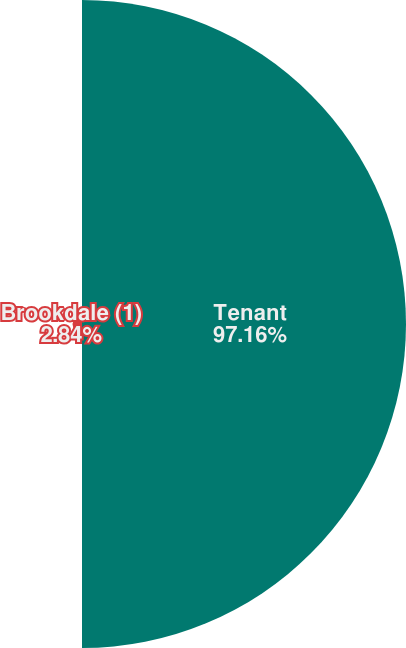Convert chart. <chart><loc_0><loc_0><loc_500><loc_500><pie_chart><fcel>Tenant<fcel>Brookdale (1)<nl><fcel>97.16%<fcel>2.84%<nl></chart> 